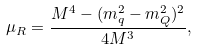<formula> <loc_0><loc_0><loc_500><loc_500>\mu _ { R } = \frac { M ^ { 4 } - ( m ^ { 2 } _ { q } - m ^ { 2 } _ { Q } ) ^ { 2 } } { 4 M ^ { 3 } } ,</formula> 